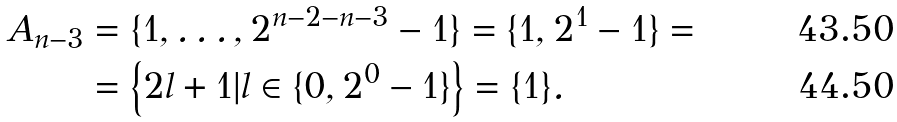<formula> <loc_0><loc_0><loc_500><loc_500>A _ { n - 3 } & = \{ 1 , \dots , 2 ^ { n - 2 - n - 3 } - 1 \} = \{ 1 , 2 ^ { 1 } - 1 \} = \\ & = \left \{ 2 l + 1 | l \in \{ 0 , 2 ^ { 0 } - 1 \} \right \} = \{ 1 \} .</formula> 